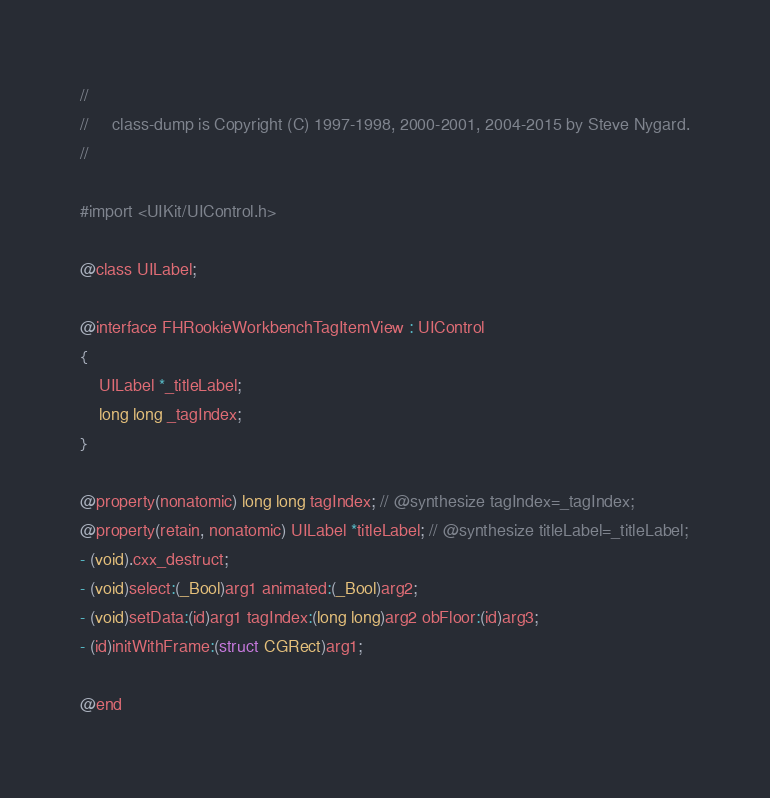<code> <loc_0><loc_0><loc_500><loc_500><_C_>//
//     class-dump is Copyright (C) 1997-1998, 2000-2001, 2004-2015 by Steve Nygard.
//

#import <UIKit/UIControl.h>

@class UILabel;

@interface FHRookieWorkbenchTagItemView : UIControl
{
    UILabel *_titleLabel;
    long long _tagIndex;
}

@property(nonatomic) long long tagIndex; // @synthesize tagIndex=_tagIndex;
@property(retain, nonatomic) UILabel *titleLabel; // @synthesize titleLabel=_titleLabel;
- (void).cxx_destruct;
- (void)select:(_Bool)arg1 animated:(_Bool)arg2;
- (void)setData:(id)arg1 tagIndex:(long long)arg2 obFloor:(id)arg3;
- (id)initWithFrame:(struct CGRect)arg1;

@end

</code> 